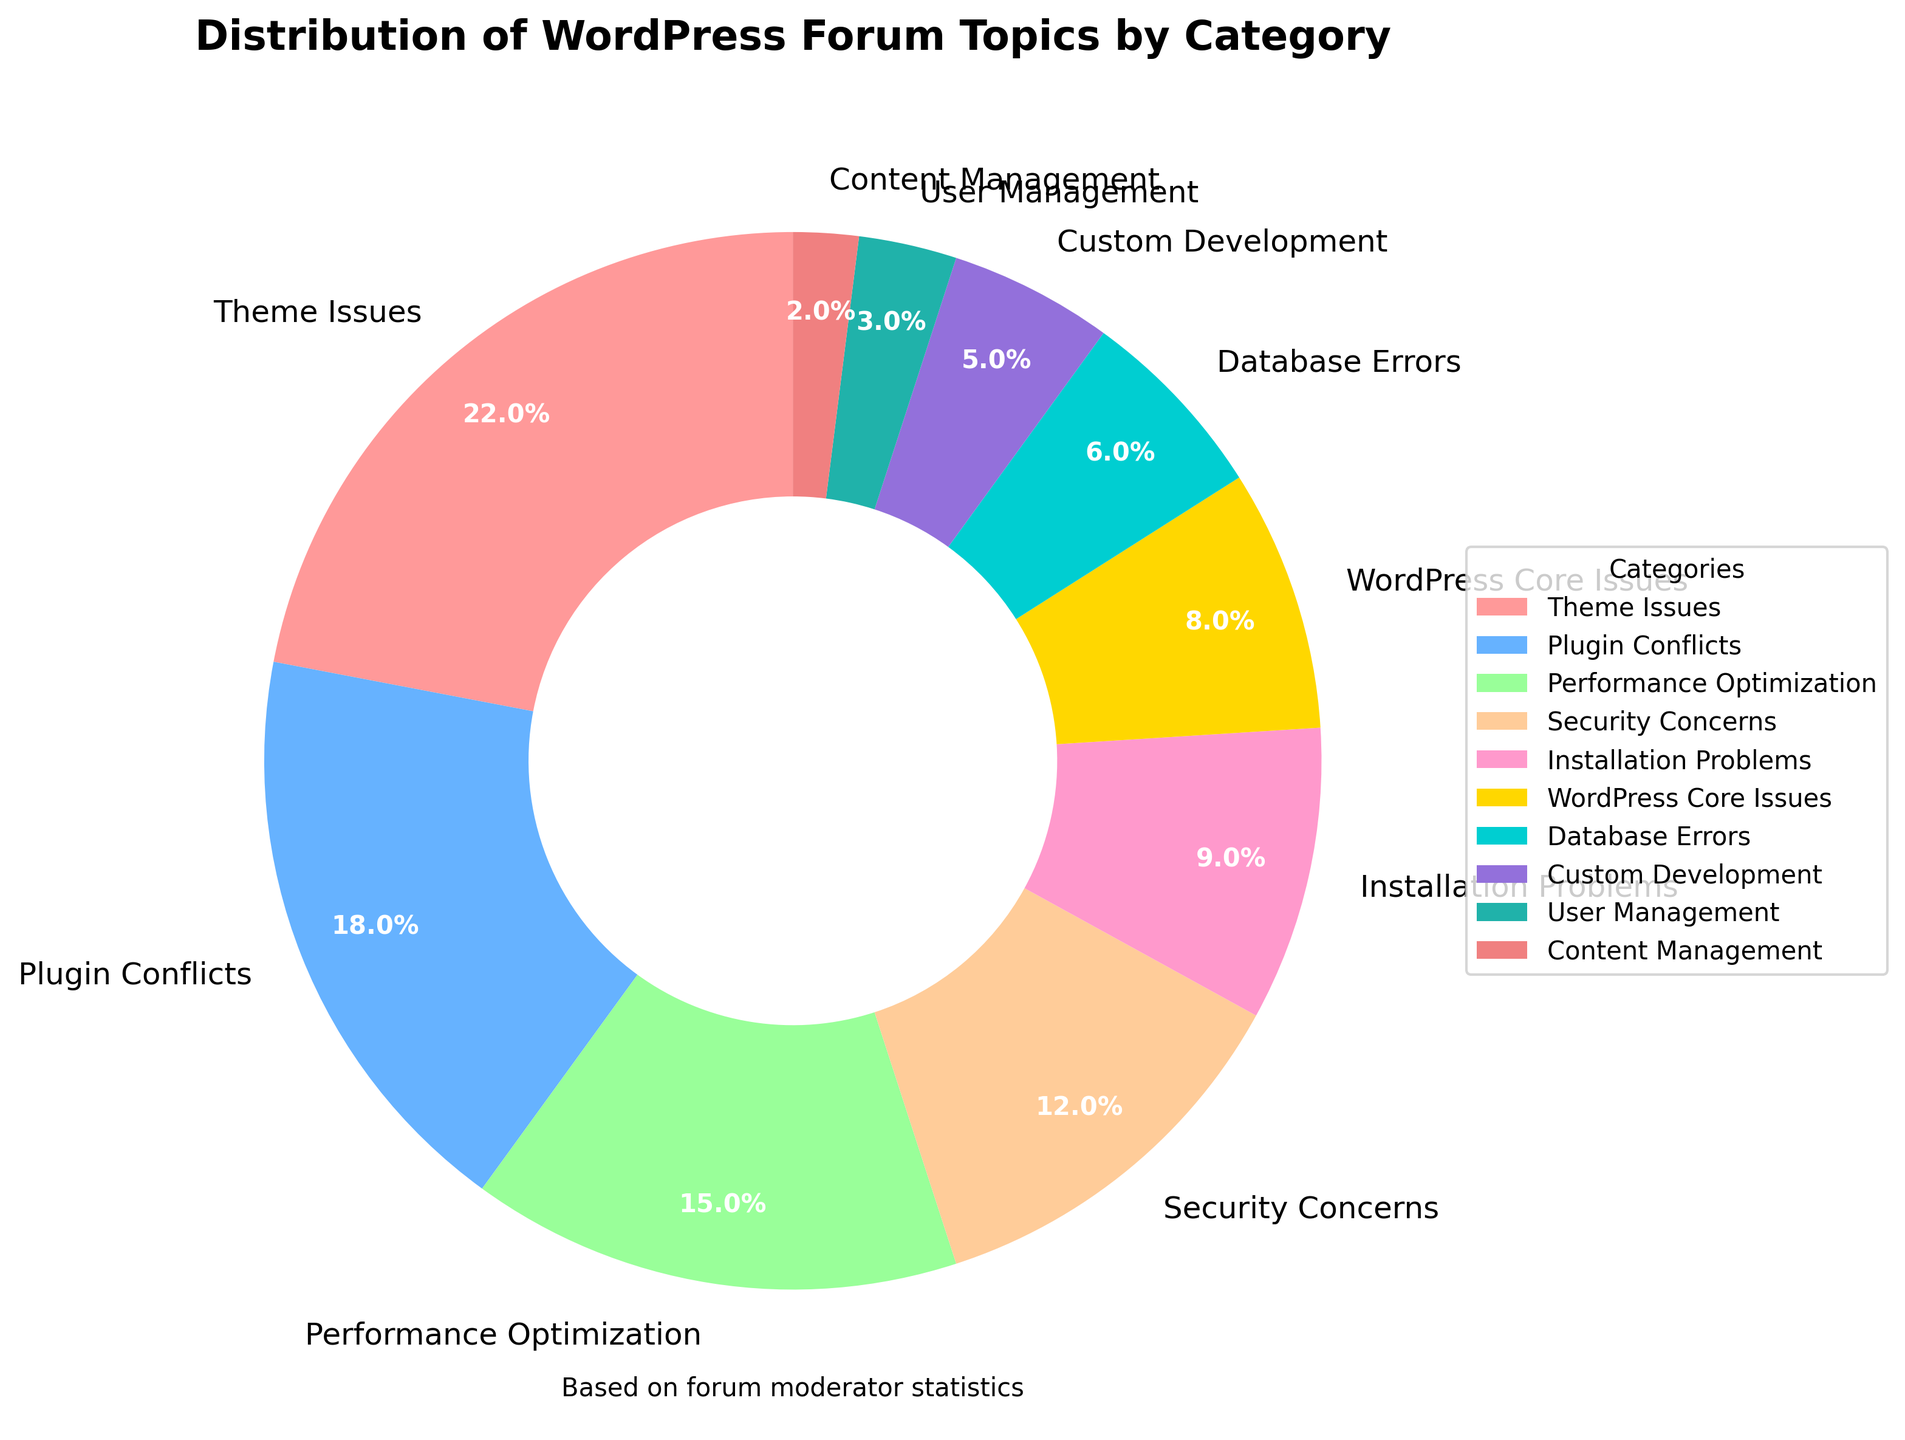What category represents the largest percentage of WordPress forum topics? The figure shows a pie chart with the largest segment corresponding to "Theme Issues". The percentage label confirms this.
Answer: Theme Issues What is the combined percentage of topics related to Security Concerns and Database Errors? Security Concerns (12%) + Database Errors (6%) = 18%. Add the given percentages for these categories to find the combined percentage.
Answer: 18% Which category has the smallest percentage of forum topics? The smallest slice of the pie chart represents "Content Management" with 2%.
Answer: Content Management Is the percentage of topics related to Plugin Conflicts greater than those related to Performance Optimization? Comparing the segments for Plugin Conflicts (18%) and Performance Optimization (15%), Plugin Conflicts are indeed greater.
Answer: Yes What is the difference between the percentage of Installation Problems and Custom Development topics? Subtract the percentage of Custom Development (5%) from Installation Problems (9%) to get the difference: 9% - 5% = 4%.
Answer: 4% Which two categories together account for about one-third of all topics? One-third of 100% is approximately 33%. The two categories whose percentages sum closest to this are Theme Issues (22%) + Plugin Conflicts (18%) = 40%. Adjusting, Plugin Conflicts (18%) and Performance Optimization (15%) sum to 33%.
Answer: Plugin Conflicts and Performance Optimization Are User Management topics less frequent than WordPress Core Issues topics? Comparing the segments for User Management (3%) and WordPress Core Issues (8%): User Management is indeed less frequent.
Answer: Yes What would be the percentage if you combined Theme Issues, Plugin Conflicts, and Performance Optimization? Add the given percentages: Theme Issues (22%) + Plugin Conflicts (18%) + Performance Optimization (15%) = 55%.
Answer: 55% What is the total percentage for the categories related to technical issues (Theme Issues, Plugin Conflicts, Installation Problems, WordPress Core Issues, Database Errors)? Summing these categories: Theme Issues (22%) + Plugin Conflicts (18%) + Installation Problems (9%) + WordPress Core Issues (8%) + Database Errors (6%) = 63%.
Answer: 63% Which category has a greater percentage: Custom Development or User Management? The pie chart segment for Custom Development (5%) is greater than that for User Management (3%).
Answer: Custom Development 